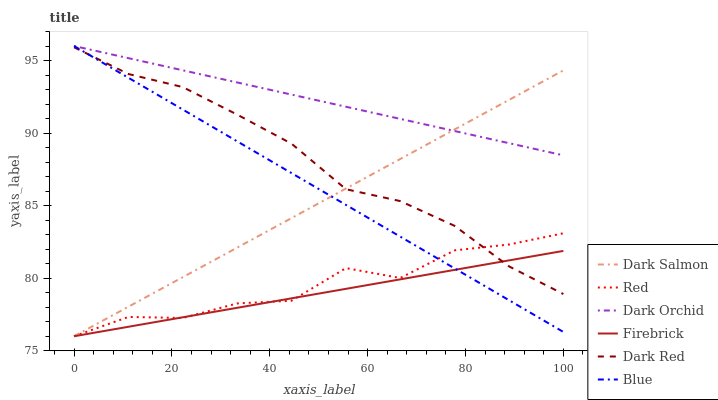Does Firebrick have the minimum area under the curve?
Answer yes or no. Yes. Does Dark Orchid have the maximum area under the curve?
Answer yes or no. Yes. Does Dark Red have the minimum area under the curve?
Answer yes or no. No. Does Dark Red have the maximum area under the curve?
Answer yes or no. No. Is Dark Salmon the smoothest?
Answer yes or no. Yes. Is Red the roughest?
Answer yes or no. Yes. Is Dark Red the smoothest?
Answer yes or no. No. Is Dark Red the roughest?
Answer yes or no. No. Does Firebrick have the lowest value?
Answer yes or no. Yes. Does Dark Red have the lowest value?
Answer yes or no. No. Does Dark Orchid have the highest value?
Answer yes or no. Yes. Does Dark Red have the highest value?
Answer yes or no. No. Is Dark Red less than Dark Orchid?
Answer yes or no. Yes. Is Dark Orchid greater than Firebrick?
Answer yes or no. Yes. Does Dark Red intersect Red?
Answer yes or no. Yes. Is Dark Red less than Red?
Answer yes or no. No. Is Dark Red greater than Red?
Answer yes or no. No. Does Dark Red intersect Dark Orchid?
Answer yes or no. No. 